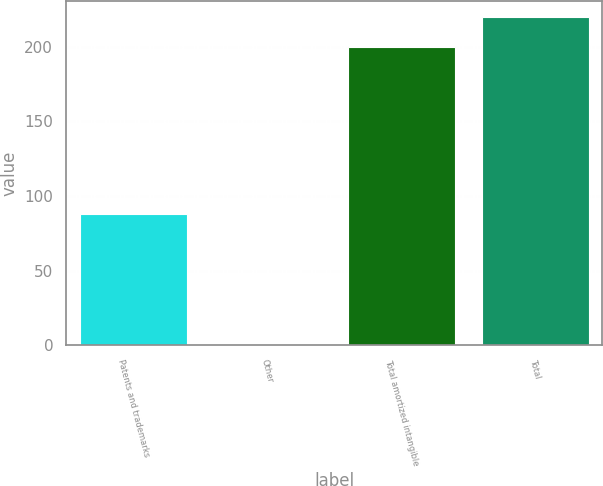<chart> <loc_0><loc_0><loc_500><loc_500><bar_chart><fcel>Patents and trademarks<fcel>Other<fcel>Total amortized intangible<fcel>Total<nl><fcel>88<fcel>1<fcel>200<fcel>219.9<nl></chart> 